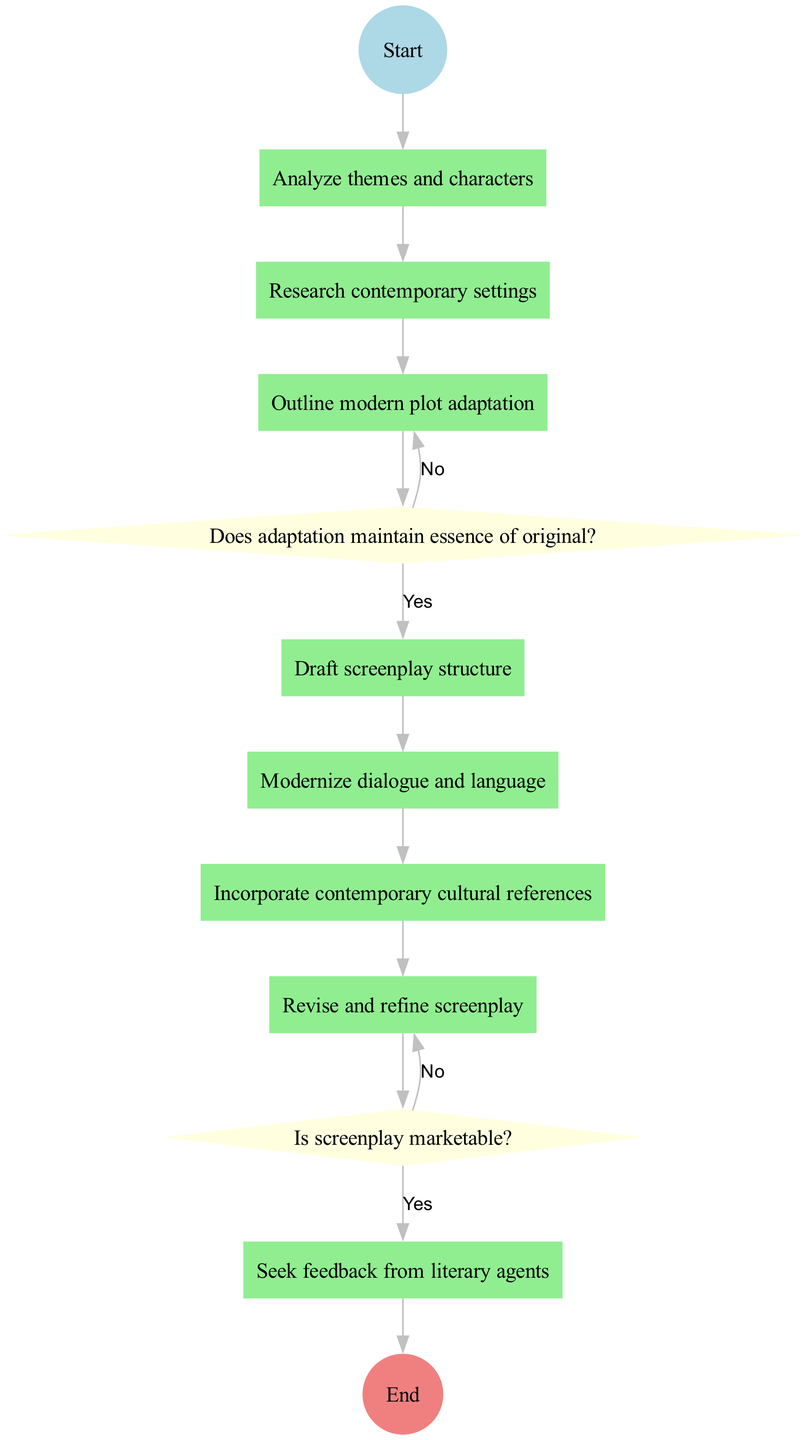What is the first activity in the adaptation process? The diagram starts with the node labeled "Read great-great-grandmother's novel," which is the first activity that initiates the adaptation workflow.
Answer: Read great-great-grandmother's novel How many activities are involved in the adaptation process? Counting the activities listed in the diagram, there are a total of eight activities that sequentially contribute to the adaptation process.
Answer: Eight What is the decision after drafting the screenplay structure? The diagram indicates that after drafting the screenplay structure, the next step is to ask the decision question, "Does adaptation maintain essence of original?" This decision determines the next action taken.
Answer: Does adaptation maintain essence of original? What is the outcome if the screenplay is found to be marketable? According to the diagram, if the screenplay is determined to be marketable (i.e., the answer to the decision question is "Yes"), the next step is to "Proceed to pitching."
Answer: Proceed to pitching What happens if the adaptation does not maintain the essence of the original? The diagram states that if the adaptation does not maintain the essence of the original (i.e., the answer is "No"), the flow leads back to "Revise adaptation," indicating a need for reworking the screenplay.
Answer: Revise adaptation How many decision nodes are in the diagram? There are two decision nodes depicted in the diagram, each corresponding to crucial points in the adaptation process where a decision must be made.
Answer: Two What is the final step in the adaptation process? The last node in the diagram represents the outcome of the entire process, which is to "Submit screenplay to production companies," marking the completion of the adaptation workflow.
Answer: Submit screenplay to production companies What action follows the activity of revising the screenplay? The diagram illustrates that after revising the screenplay, the next step is to seek feedback from literary agents before proceeding to any further decisions.
Answer: Seek feedback from literary agents What is the color of the end node? The end node, which signifies the conclusion of the adaptation process, is colored light coral according to the color scheme used in the diagram.
Answer: Light coral 